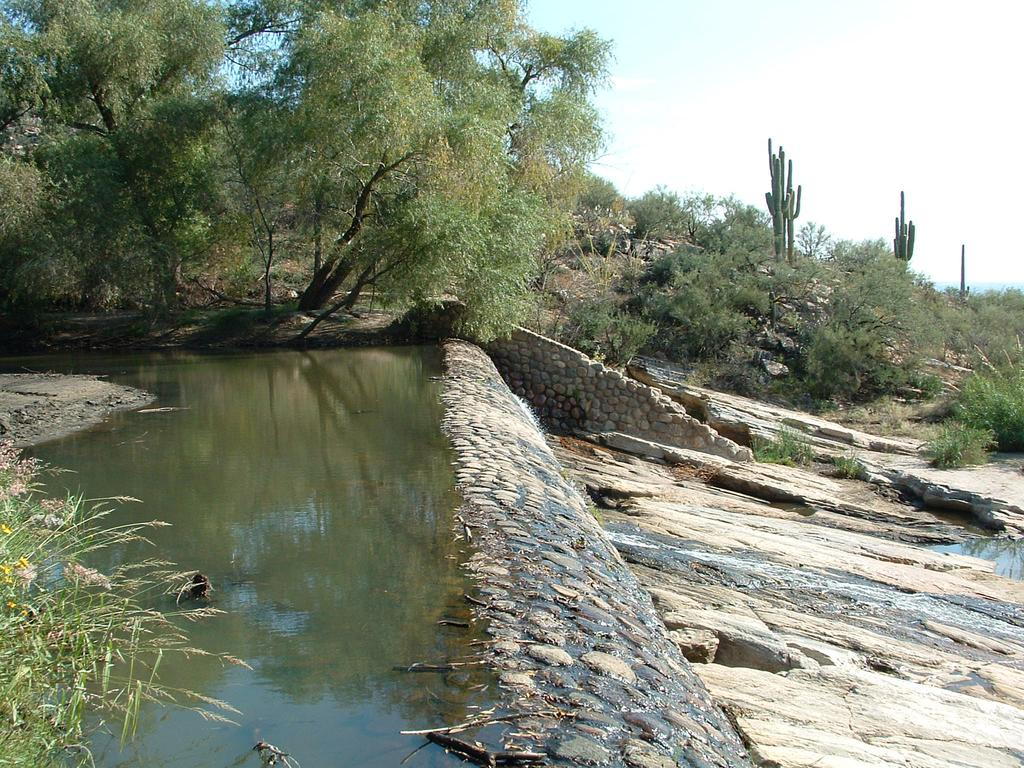What is the primary element visible in the image? There is water in the image. What other natural features can be seen in the image? There are rocks, plants, trees, and cactus plants in the image. What is visible in the background of the image? The sky is visible in the background of the image. How many men are swimming in the water in the image? There are no men present in the image; it features water, rocks, plants, trees, and cactus plants. Can you see any snakes or frogs in the image? There are no snakes or frogs visible in the image. 